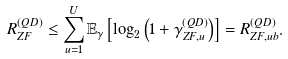<formula> <loc_0><loc_0><loc_500><loc_500>R _ { Z F } ^ { ( Q D ) } \leq \sum _ { u = 1 } ^ { U } \mathbb { E } _ { \gamma } \left [ \log _ { 2 } \left ( 1 + \gamma _ { Z F , u } ^ { ( Q D ) } \right ) \right ] = R _ { Z F , u b } ^ { ( Q D ) } .</formula> 